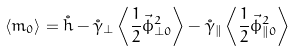Convert formula to latex. <formula><loc_0><loc_0><loc_500><loc_500>\langle m _ { 0 } \rangle = \mathring { h } - \mathring { \gamma } _ { \perp } \left \langle \frac { 1 } { 2 } \vec { \phi } _ { \perp 0 } ^ { 2 } \right \rangle - \mathring { \gamma } _ { \| } \left \langle \frac { 1 } { 2 } \vec { \phi } _ { \| 0 } ^ { 2 } \right \rangle</formula> 